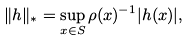Convert formula to latex. <formula><loc_0><loc_0><loc_500><loc_500>\| h \| _ { * } = \sup _ { x \in S } \rho ( x ) ^ { - 1 } | h ( x ) | ,</formula> 